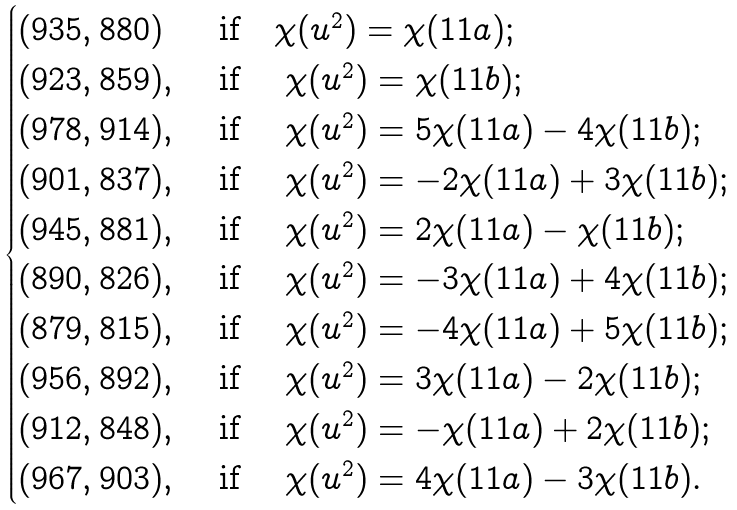Convert formula to latex. <formula><loc_0><loc_0><loc_500><loc_500>\begin{cases} ( 9 3 5 , 8 8 0 ) & \text { if} \quad \chi ( u ^ { 2 } ) = \chi ( 1 1 a ) ; \\ ( 9 2 3 , 8 5 9 ) , & \text { if } \quad \chi ( u ^ { 2 } ) = \chi ( 1 1 b ) ; \\ ( 9 7 8 , 9 1 4 ) , & \text { if } \quad \chi ( u ^ { 2 } ) = 5 \chi ( 1 1 a ) - 4 \chi ( 1 1 b ) ; \\ ( 9 0 1 , 8 3 7 ) , & \text { if } \quad \chi ( u ^ { 2 } ) = - 2 \chi ( 1 1 a ) + 3 \chi ( 1 1 b ) ; \\ ( 9 4 5 , 8 8 1 ) , & \text { if } \quad \chi ( u ^ { 2 } ) = 2 \chi ( 1 1 a ) - \chi ( 1 1 b ) ; \\ ( 8 9 0 , 8 2 6 ) , & \text { if } \quad \chi ( u ^ { 2 } ) = - 3 \chi ( 1 1 a ) + 4 \chi ( 1 1 b ) ; \\ ( 8 7 9 , 8 1 5 ) , & \text { if } \quad \chi ( u ^ { 2 } ) = - 4 \chi ( 1 1 a ) + 5 \chi ( 1 1 b ) ; \\ ( 9 5 6 , 8 9 2 ) , & \text { if } \quad \chi ( u ^ { 2 } ) = 3 \chi ( 1 1 a ) - 2 \chi ( 1 1 b ) ; \\ ( 9 1 2 , 8 4 8 ) , & \text { if } \quad \chi ( u ^ { 2 } ) = - \chi ( 1 1 a ) + 2 \chi ( 1 1 b ) ; \\ ( 9 6 7 , 9 0 3 ) , & \text { if } \quad \chi ( u ^ { 2 } ) = 4 \chi ( 1 1 a ) - 3 \chi ( 1 1 b ) . \\ \end{cases}</formula> 